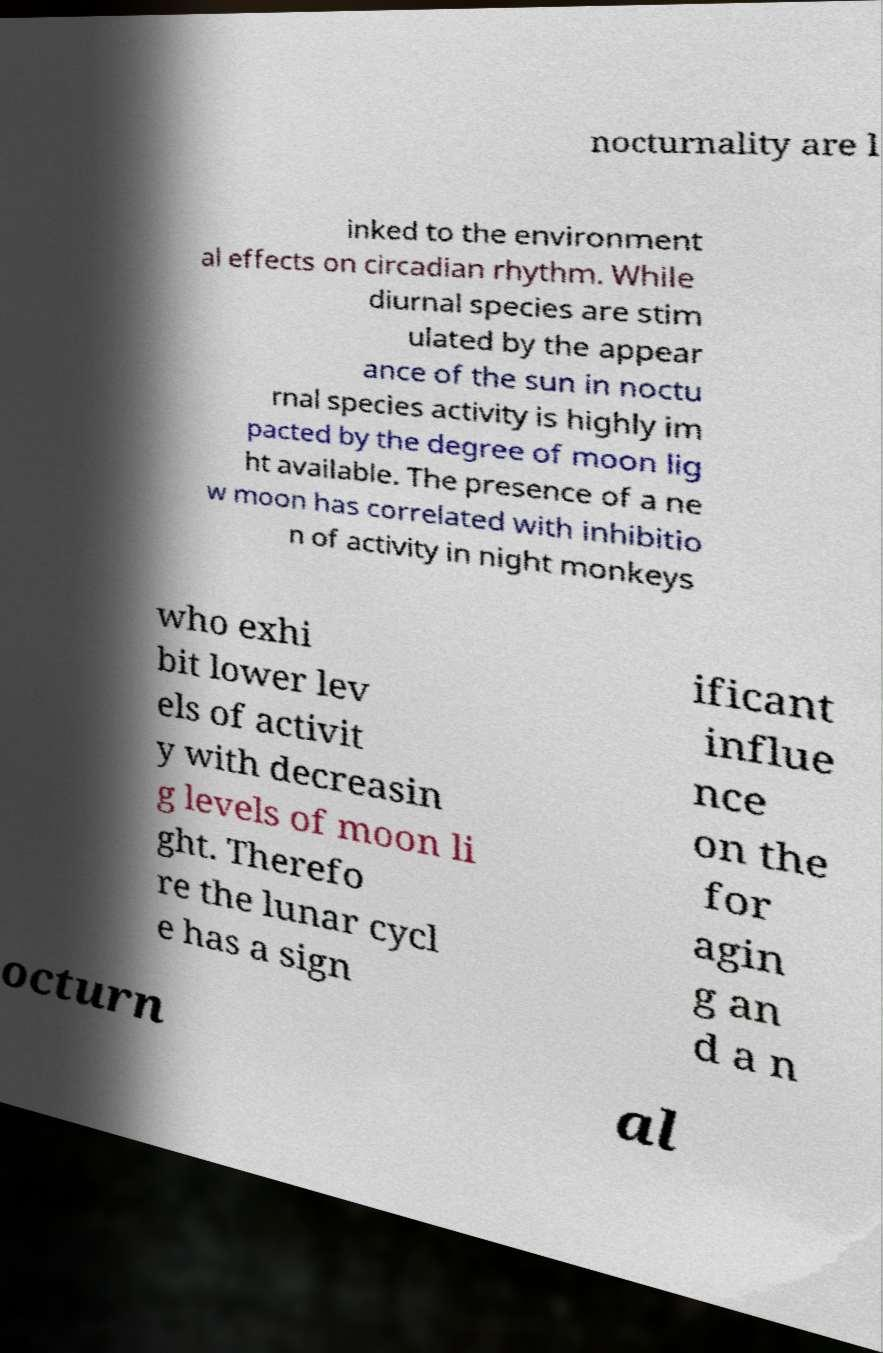Can you read and provide the text displayed in the image?This photo seems to have some interesting text. Can you extract and type it out for me? nocturnality are l inked to the environment al effects on circadian rhythm. While diurnal species are stim ulated by the appear ance of the sun in noctu rnal species activity is highly im pacted by the degree of moon lig ht available. The presence of a ne w moon has correlated with inhibitio n of activity in night monkeys who exhi bit lower lev els of activit y with decreasin g levels of moon li ght. Therefo re the lunar cycl e has a sign ificant influe nce on the for agin g an d a n octurn al 